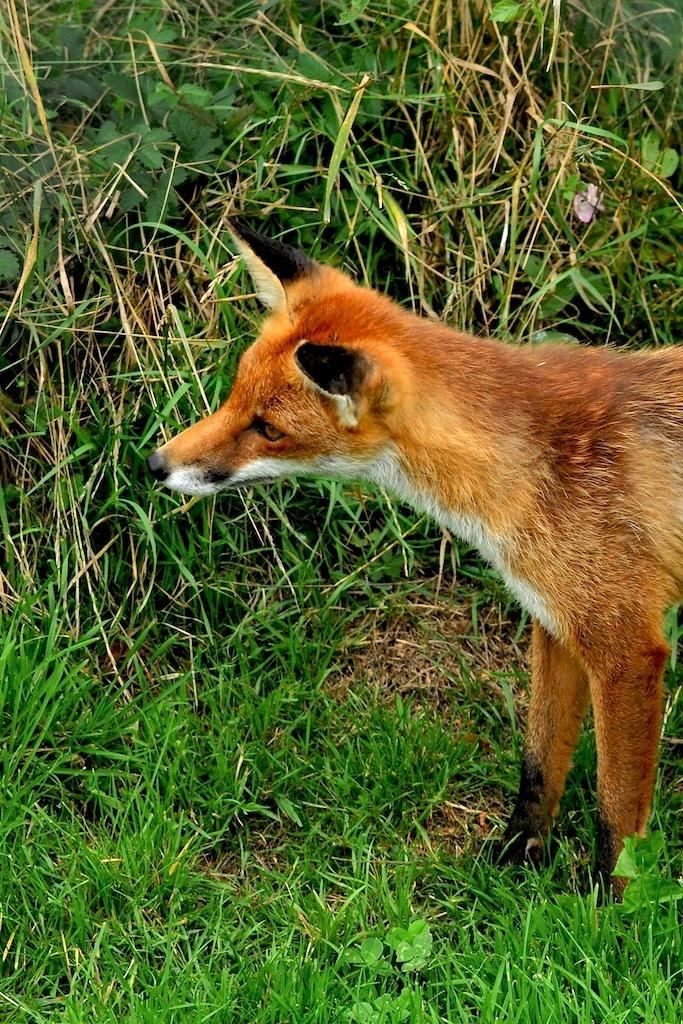What animal is present in the image? There is a dog in the image. On which side of the image is the dog located? The dog is on the right side of the image. What type of environment is visible in the background of the image? There is grass in the background of the image. What religious offering is the dog making in the image? There is no religious offering present in the image; it simply features a dog on the right side of the image with grass in the background. 